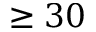Convert formula to latex. <formula><loc_0><loc_0><loc_500><loc_500>\geq 3 0</formula> 